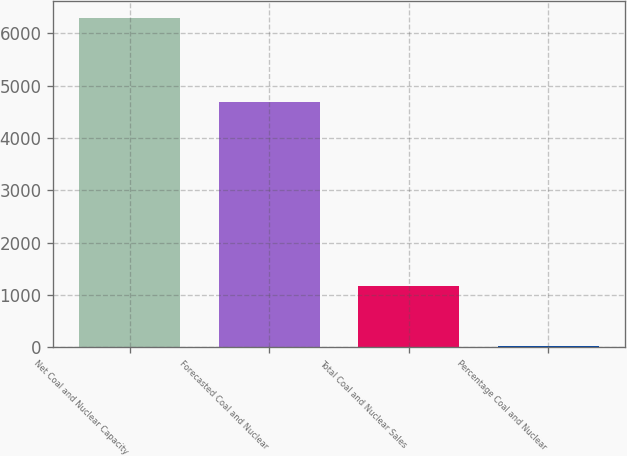Convert chart to OTSL. <chart><loc_0><loc_0><loc_500><loc_500><bar_chart><fcel>Net Coal and Nuclear Capacity<fcel>Forecasted Coal and Nuclear<fcel>Total Coal and Nuclear Sales<fcel>Percentage Coal and Nuclear<nl><fcel>6290<fcel>4692<fcel>1171<fcel>25<nl></chart> 